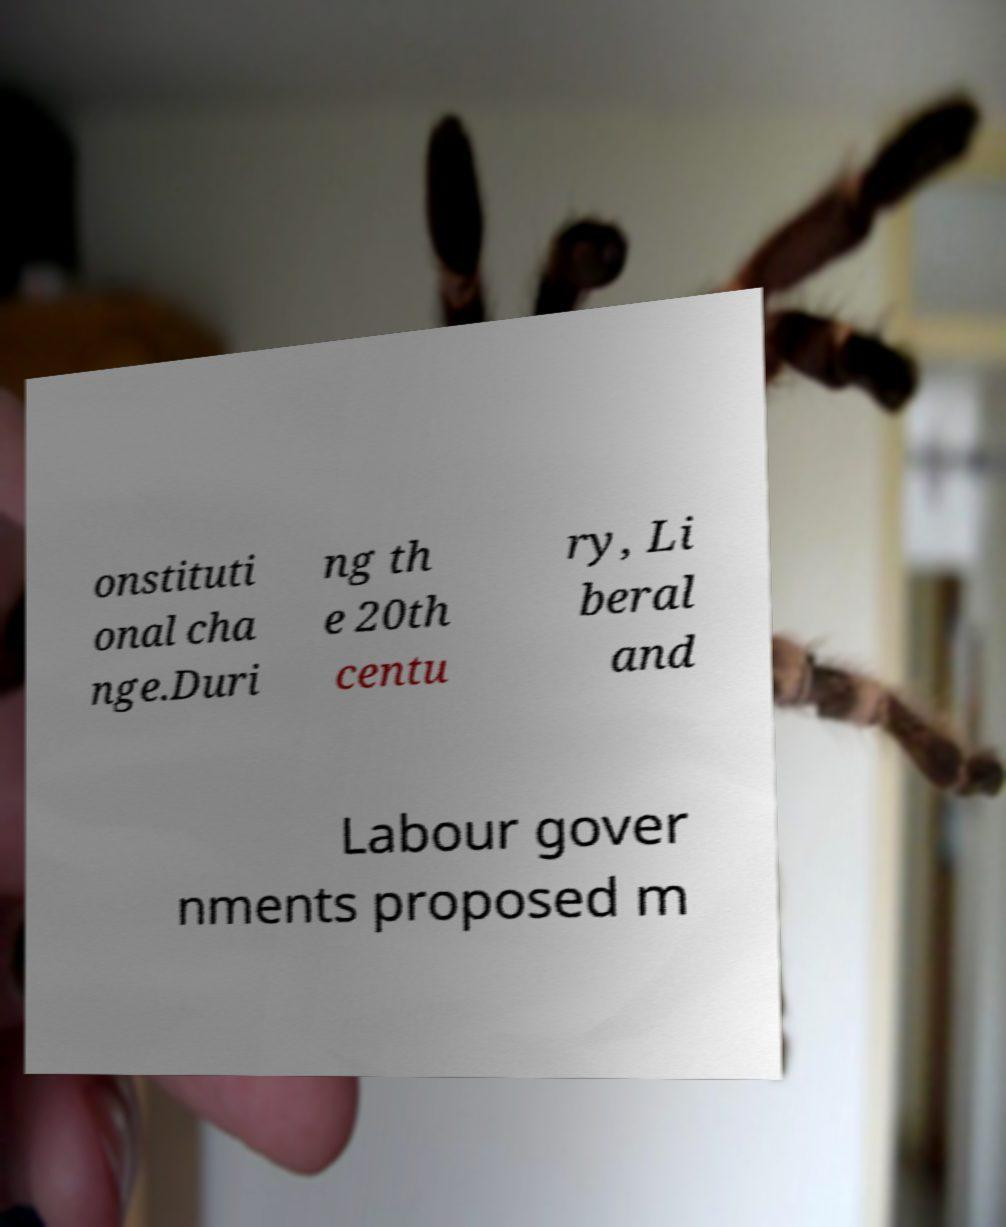What messages or text are displayed in this image? I need them in a readable, typed format. onstituti onal cha nge.Duri ng th e 20th centu ry, Li beral and Labour gover nments proposed m 